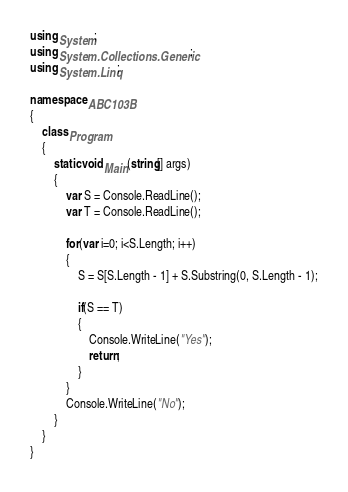<code> <loc_0><loc_0><loc_500><loc_500><_C#_>using System;
using System.Collections.Generic;
using System.Linq;

namespace ABC103B
{
    class Program
    {
        static void Main(string[] args)
        {
            var S = Console.ReadLine();
            var T = Console.ReadLine();

            for(var i=0; i<S.Length; i++)
            {
                S = S[S.Length - 1] + S.Substring(0, S.Length - 1);

                if(S == T)
                {
                    Console.WriteLine("Yes");
                    return;
                }
            }
            Console.WriteLine("No");
        }
    }
}
</code> 